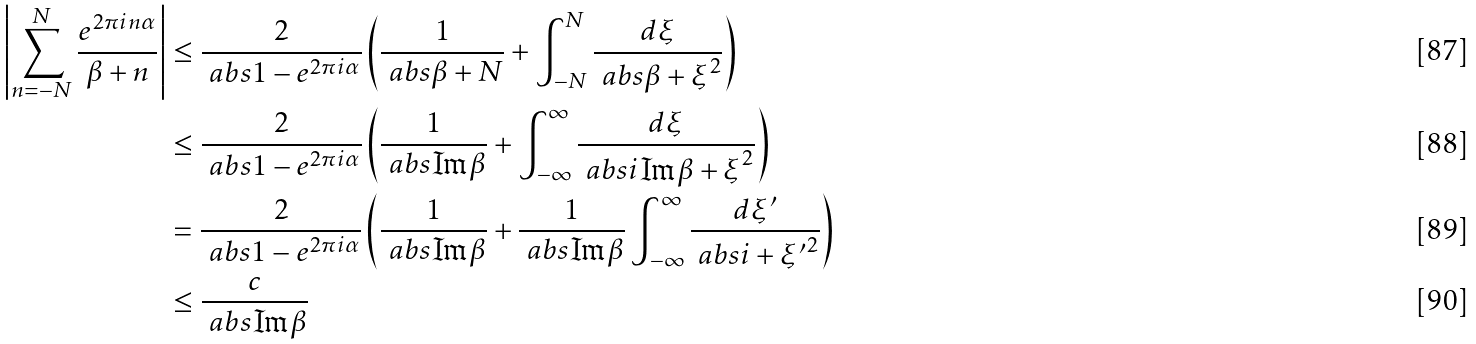Convert formula to latex. <formula><loc_0><loc_0><loc_500><loc_500>\left | \sum _ { n = - N } ^ { N } \frac { e ^ { 2 \pi i n \alpha } } { \beta + n } \right | & \leq \frac { 2 } { \ a b s { 1 - e ^ { 2 \pi i \alpha } } } \left ( \frac { 1 } { \ a b s { \beta + N } } + \int _ { - N } ^ { N } \frac { d \xi } { \ a b s { \beta + \xi } ^ { 2 } } \right ) \\ & \leq \frac { 2 } { \ a b s { 1 - e ^ { 2 \pi i \alpha } } } \left ( \frac { 1 } { \ a b s { \Im \beta } } + \int _ { - \infty } ^ { \infty } \frac { d \xi } { \ a b s { i \Im \beta + \xi } ^ { 2 } } \right ) \\ & = \frac { 2 } { \ a b s { 1 - e ^ { 2 \pi i \alpha } } } \left ( \frac { 1 } { \ a b s { \Im \beta } } + \frac { 1 } { \ a b s { \Im \beta } } \int _ { - \infty } ^ { \infty } \frac { d \xi ^ { \prime } } { \ a b s { i + \xi ^ { \prime } } ^ { 2 } } \right ) \\ & \leq \frac { c } { \ a b s { \Im \beta } }</formula> 